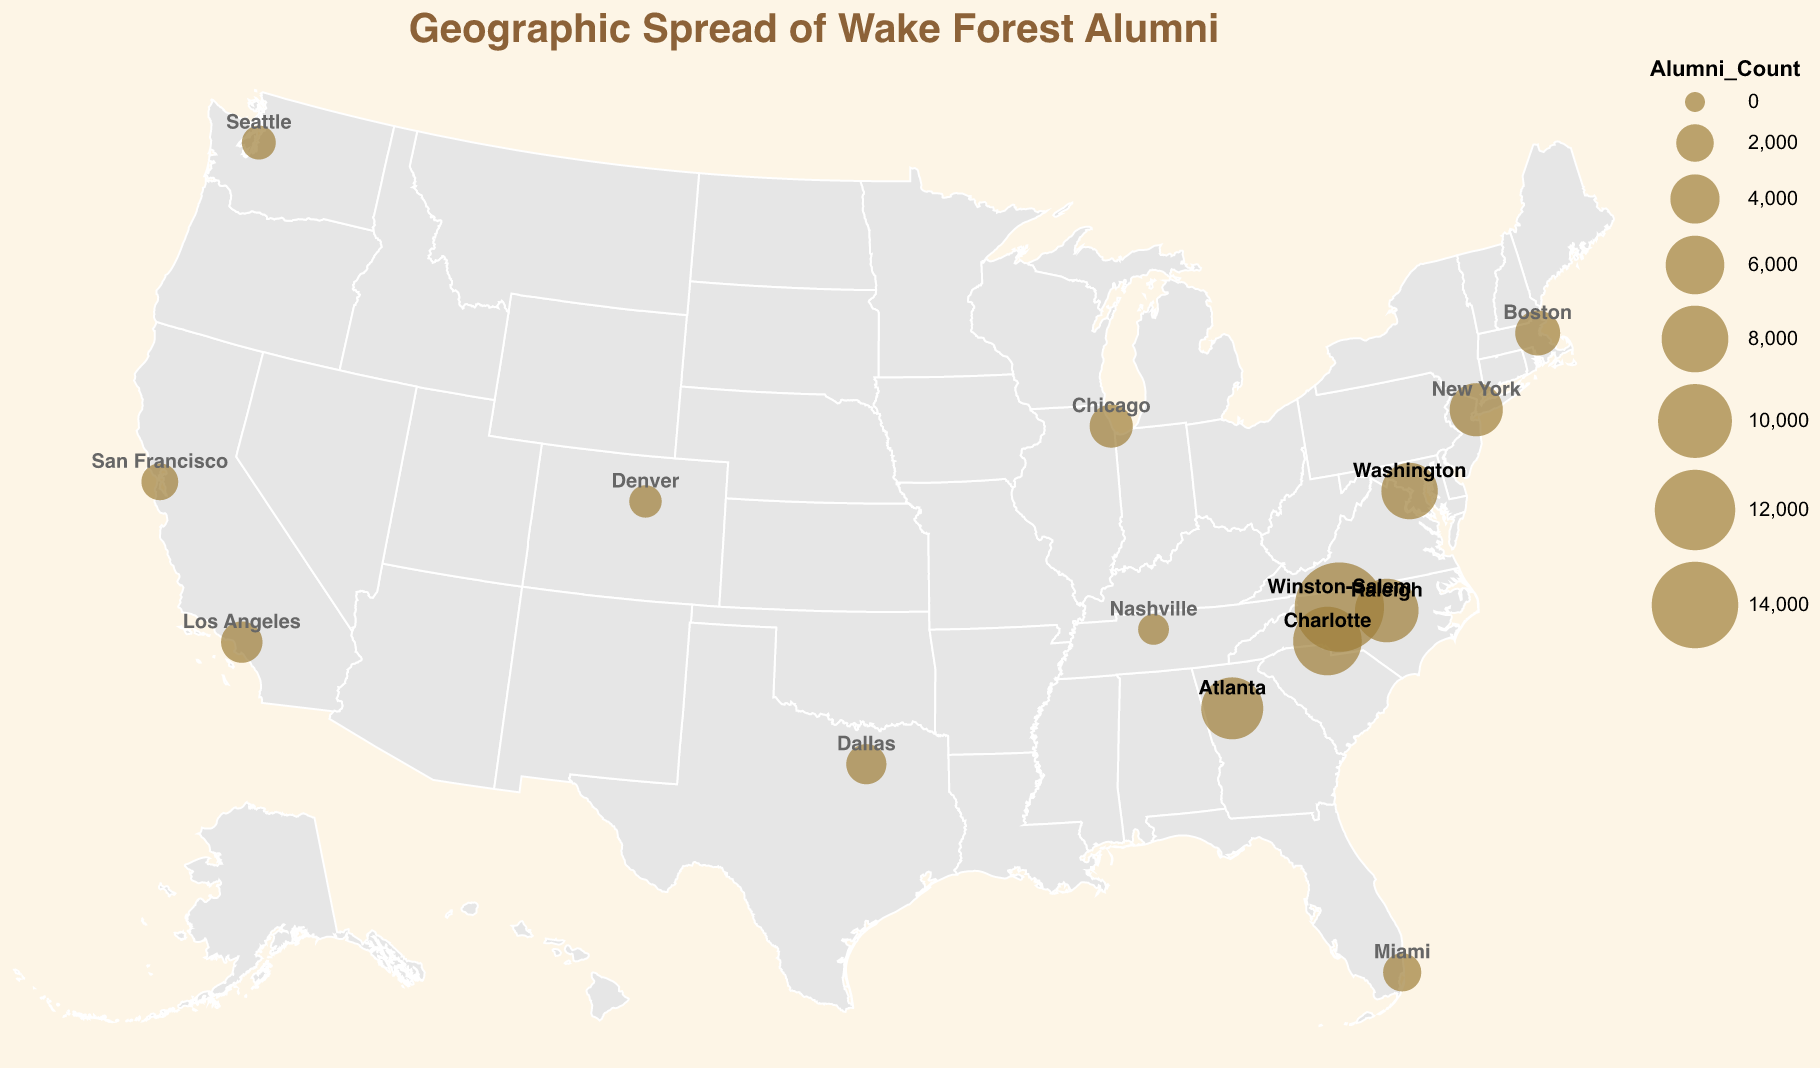Which city has the highest concentration of Wake Forest alumni? The largest circle on the geographic plot represents the city with the highest number of alumni. Observing the visual, the largest circle is over Winston-Salem, NC.
Answer: Winston-Salem, NC How many Wake Forest alumni are in Los Angeles, CA? By hovering over or looking at the tooltip for Los Angeles on the geographic plot, you can see the Alumni Count. The tooltip for Los Angeles shows 2600 alumni.
Answer: 2600 What is the signature cocktail for Chicago, IL? Hover over or look at the tooltip for Chicago on the plot. The tooltip information includes the Signature Cocktail, which for Chicago is the "Windy City Wake-arita."
Answer: Windy City Wake-arita Which city has a higher alumni count, San Francisco or Seattle? Comparing the size of the circles or referring to the tooltips, San Francisco has 1900 alumni, while Seattle has 1500 alumni. San Francisco has a higher count.
Answer: San Francisco How does the alumni count in Denver compare to that in Nashville? Hovering over the circles or checking the tooltips, Denver has 1300 alumni, whereas Nashville has 1100 alumni. Denver has a higher count than Nashville.
Answer: Denver has a higher count What is the total number of Wake Forest alumni in North Carolina? There are three cities in North Carolina on the plot: Winston-Salem (15000), Charlotte (8500), and Raleigh (7200). Summing these up: 15000 + 8500 + 7200 = 30700.
Answer: 30700 Which city has the lowest number of Wake Forest alumni in the plot? By observing the sizes of the circles and checking the tooltips, Nashville, TN, with 1100 alumni, has the smallest number on the geographic plot.
Answer: Nashville, TN What color is used to represent the locations of the alumni? The circles on the geographic plot representing alumni locations are colored in a shade of gold.
Answer: Gold How many cities have more than 5000 Wake Forest alumni? By identifying and counting the cities with circles sized for more than 5000 alumni: Winston-Salem (15000), Charlotte (8500), Raleigh (7200), and Atlanta (6800). There are four such cities.
Answer: 4 